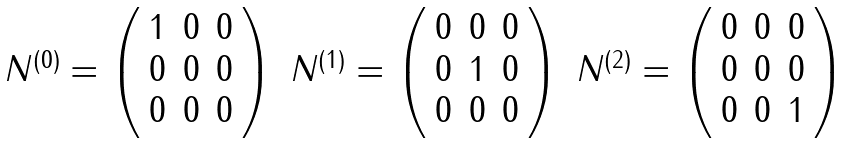Convert formula to latex. <formula><loc_0><loc_0><loc_500><loc_500>\begin{array} { c c c } N ^ { ( 0 ) } = \left ( \begin{array} { c c c } 1 & 0 & 0 \\ 0 & 0 & 0 \\ 0 & 0 & 0 \end{array} \right ) & N ^ { ( 1 ) } = \left ( \begin{array} { c c c } 0 & 0 & 0 \\ 0 & 1 & 0 \\ 0 & 0 & 0 \end{array} \right ) & N ^ { ( 2 ) } = \left ( \begin{array} { c c c } 0 & 0 & 0 \\ 0 & 0 & 0 \\ 0 & 0 & 1 \end{array} \right ) \end{array}</formula> 